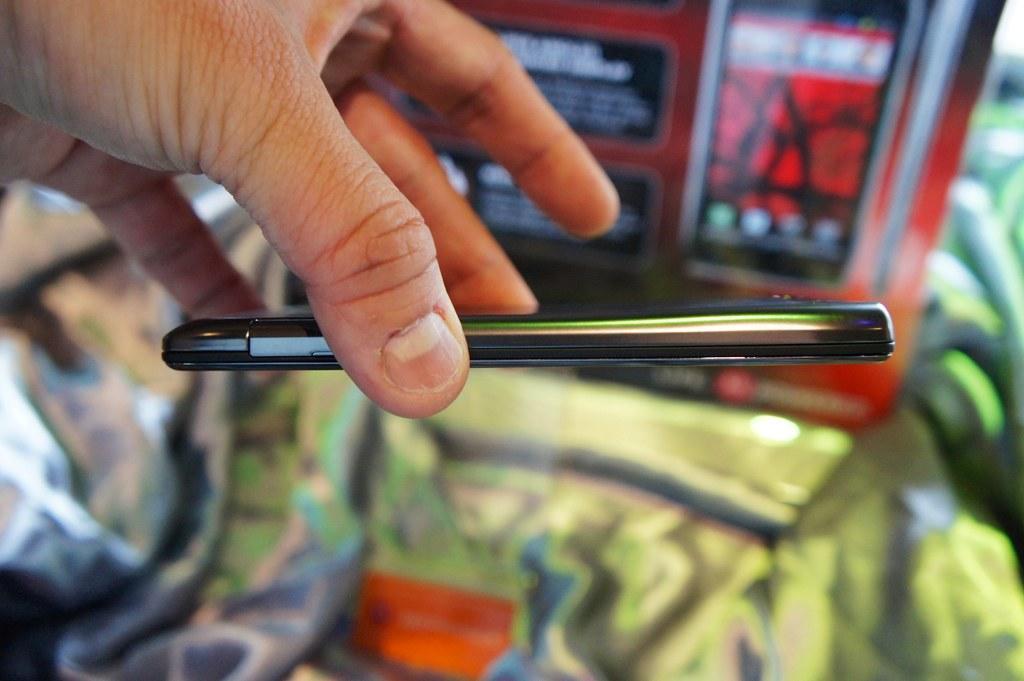How would you summarize this image in a sentence or two? In this picture we can see a person's hand and a mobile. In the background we can see some objects and it is blurry. 